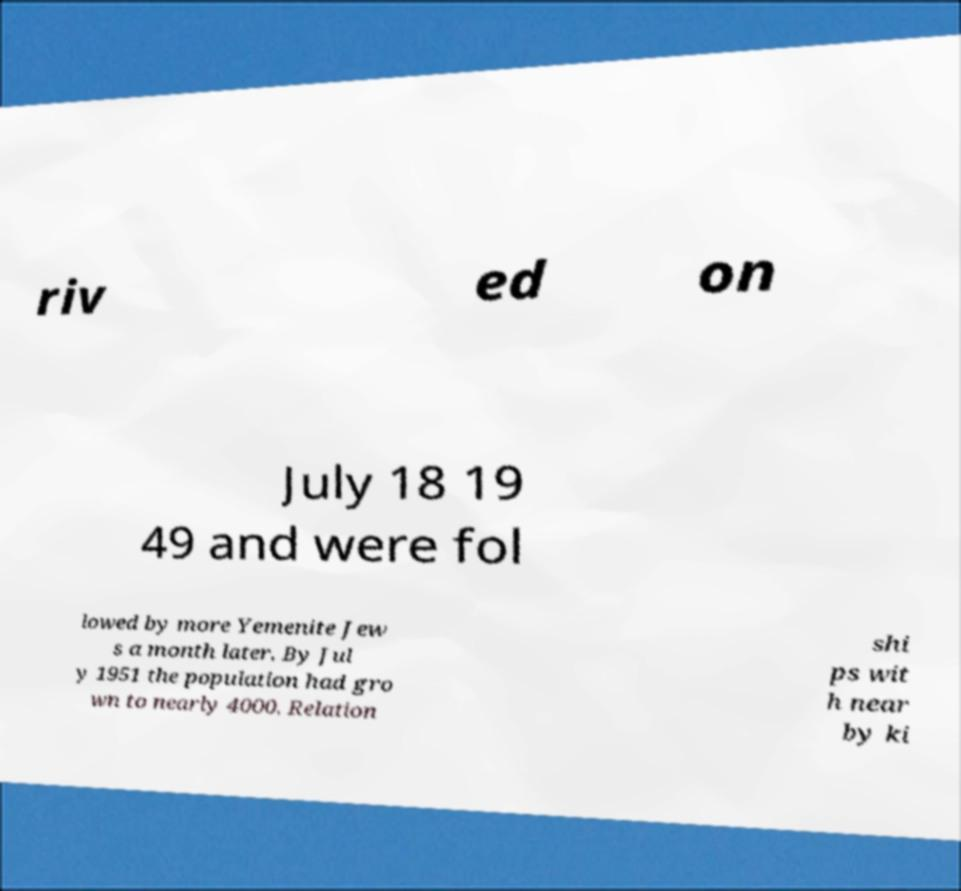Please read and relay the text visible in this image. What does it say? riv ed on July 18 19 49 and were fol lowed by more Yemenite Jew s a month later. By Jul y 1951 the population had gro wn to nearly 4000. Relation shi ps wit h near by ki 